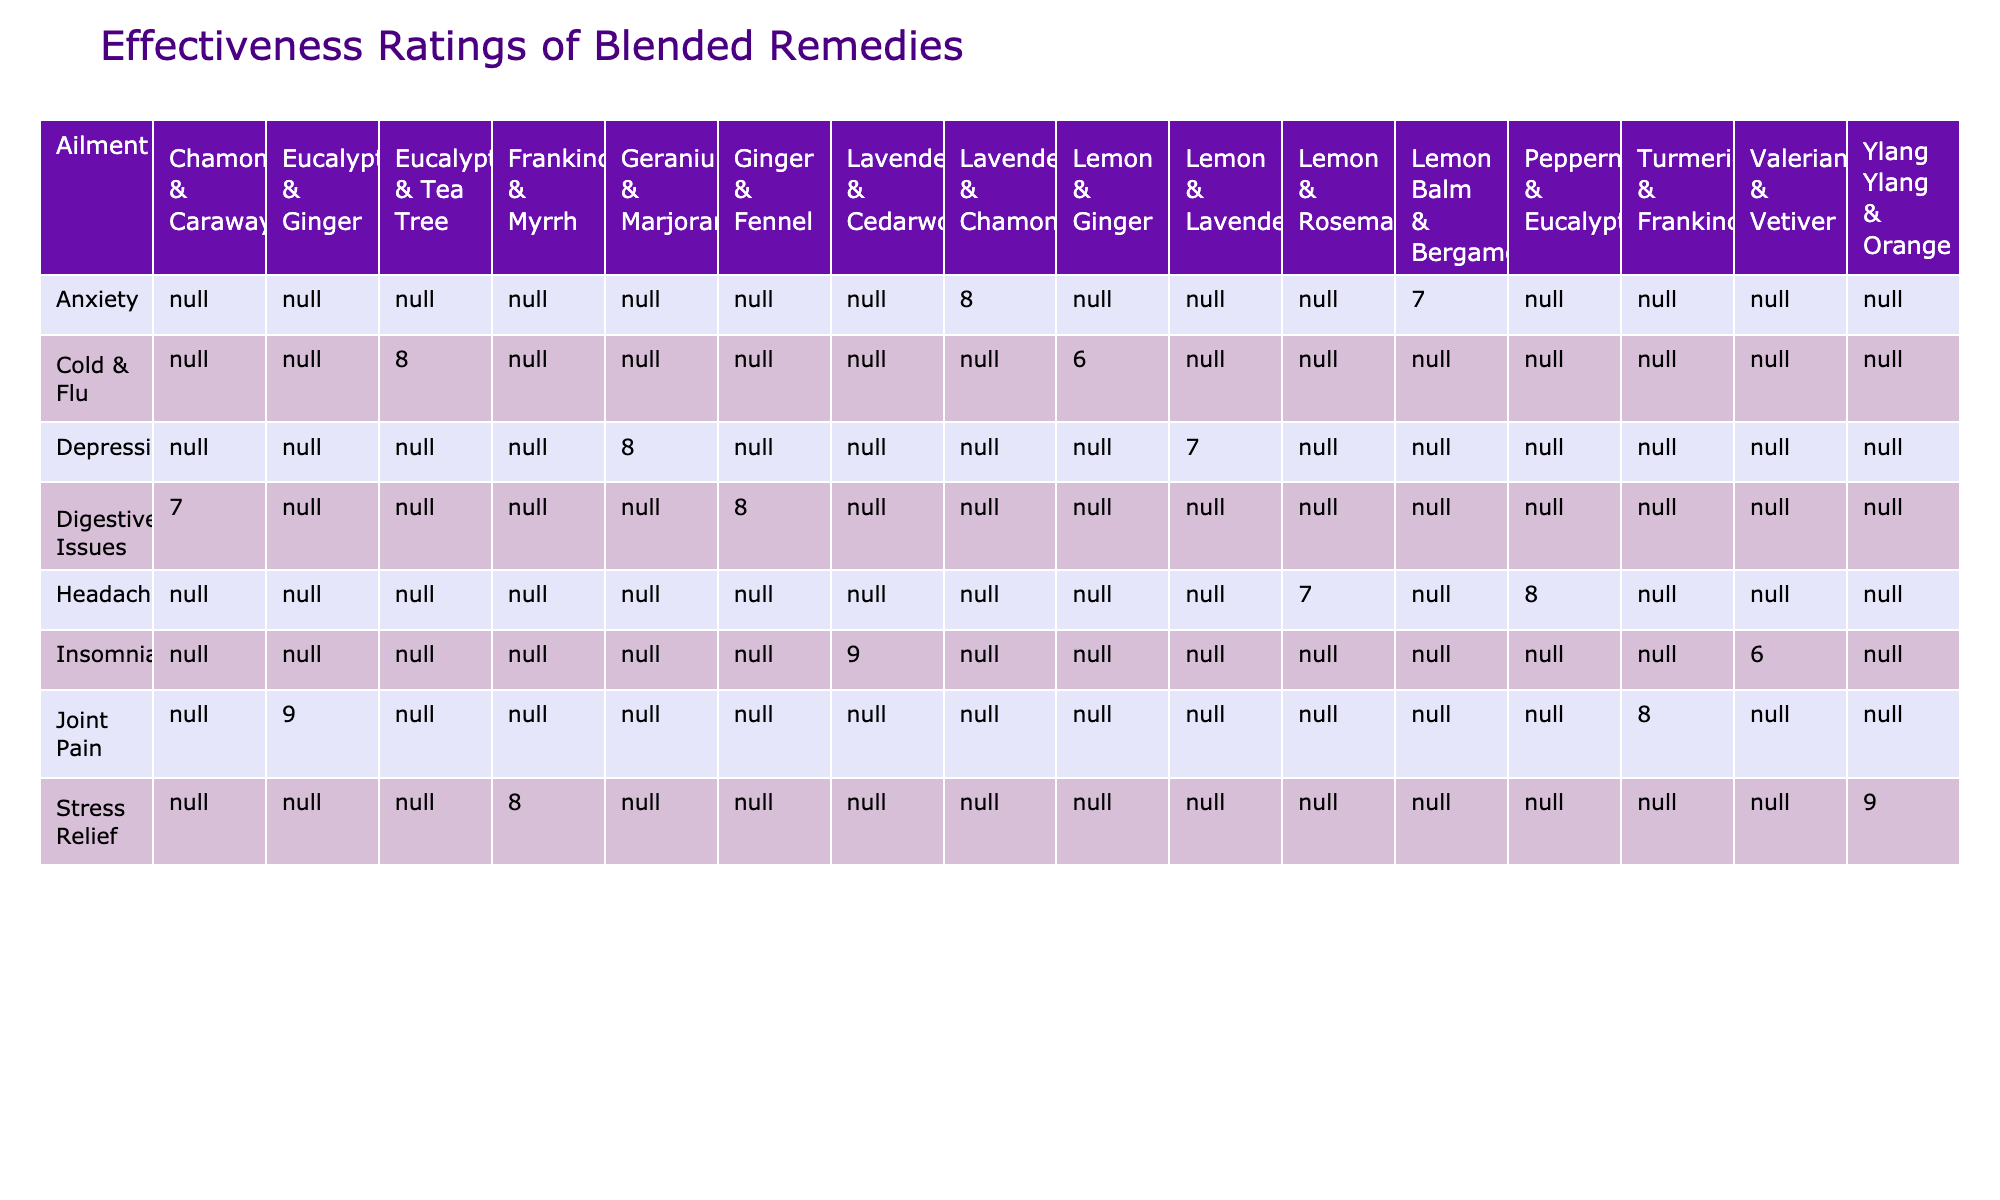What is the effectiveness rating for the Lavender & Chamomile blend for anxiety? The table lists the effectiveness ratings of various essential oil blends. For the blend Lavender & Chamomile specifically under the anxiety ailment, the effectiveness rating is directly provided in the table as 8.
Answer: 8 Which essential oil blend for insomnia has the highest effectiveness rating? In the insomnia category, the table shows the effectiveness ratings for different blends. The ratings are 9 for Lavender & Cedarwood and 6 for Valerian & Vetiver. Since 9 is the highest, Lavender & Cedarwood has the highest effectiveness.
Answer: Lavender & Cedarwood Is there a blend rated 10 for any ailment? After examining the table, it shows that no essential oil blend has an effectiveness rating of 10, as the highest ratings listed are 9.
Answer: No What is the average effectiveness rating for stress relief blends? For stress relief, the two blends are Ylang Ylang & Orange with a rating of 9 and Frankincense & Myrrh with a rating of 8. The average is calculated as (9+8)/2 = 17/2 = 8.5.
Answer: 8.5 How many client feedback counts are associated with the Eucalyptus & Ginger blend for joint pain? Looking at the joint pain category in the table, the Eucalyptus & Ginger blend has a client feedback count listed as 38.
Answer: 38 Which ailment has the blend with the highest effectiveness rating overall? The table indicates that the highest effectiveness rating is 9, which applies to the Lavender & Cedarwood blend for insomnia and the Joint Pain's Eucalyptus & Ginger blend. Both ratings are the highest for their respective ailments, but insomnia contains the highest-rated blend overall among all shown.
Answer: Insomnia Which ailment has the lowest effectiveness rating data overall based on the blends listed? By analyzing all the effectiveness ratings in the table, the lowest rating is 6, associated with the Lemon & Ginger blend for cold & flu. In comparison to all other ailments and blends, it has the lowest rating recorded.
Answer: Cold & Flu Is client feedback count higher for blends rated 9 than those rated 7? Reviewing the table, the essential oil blends rated 9 (Lavender & Cedarwood, Joint Pain's Eucalyptus & Ginger, Stress Relief's Ylang Ylang & Orange) have feedback counts that add to 50 + 38 + 32 = 120. The blends rated 7 (Lemon Balm & Bergamot, Chamomile & Caraway, and Lemon & Lavender) total to 30 + 28 + 33 = 91. Therefore, feedback counts for the 9-rated blends are indeed higher.
Answer: Yes 